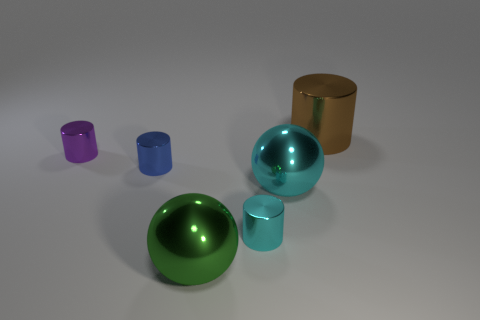What color is the tiny cylinder in front of the ball behind the big shiny thing that is left of the cyan metallic cylinder?
Provide a short and direct response. Cyan. What is the color of the big shiny ball that is to the right of the green thing?
Make the answer very short. Cyan. There is a shiny cylinder that is the same size as the green metallic ball; what color is it?
Make the answer very short. Brown. Do the cyan ball and the blue cylinder have the same size?
Your response must be concise. No. There is a big brown shiny object; how many purple cylinders are behind it?
Give a very brief answer. 0. How many things are metal balls behind the large green ball or big cyan things?
Give a very brief answer. 1. Are there more small shiny cylinders to the right of the brown metal object than large green metal spheres that are to the right of the small cyan cylinder?
Ensure brevity in your answer.  No. Is the size of the cyan shiny sphere the same as the purple object left of the cyan metal cylinder?
Your response must be concise. No. What number of cylinders are either large blue metal things or small things?
Give a very brief answer. 3. What size is the brown cylinder that is made of the same material as the purple cylinder?
Your answer should be very brief. Large. 